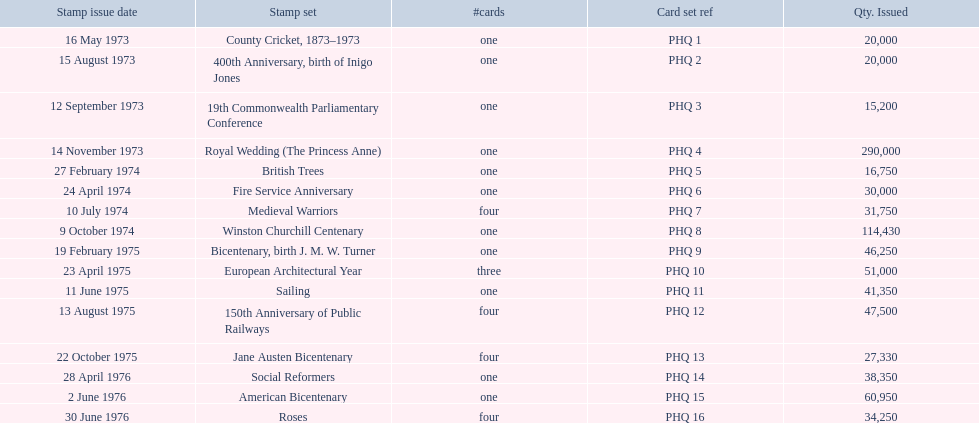Which stamp sets contained more than one card? Medieval Warriors, European Architectural Year, 150th Anniversary of Public Railways, Jane Austen Bicentenary, Roses. Of those stamp sets, which contains a unique number of cards? European Architectural Year. 